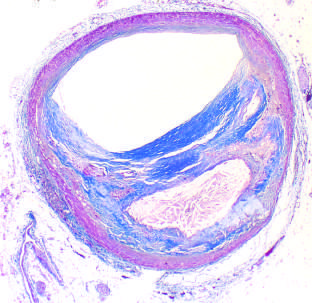what is the lumen narrowed by?
Answer the question using a single word or phrase. Eccentric lesion 